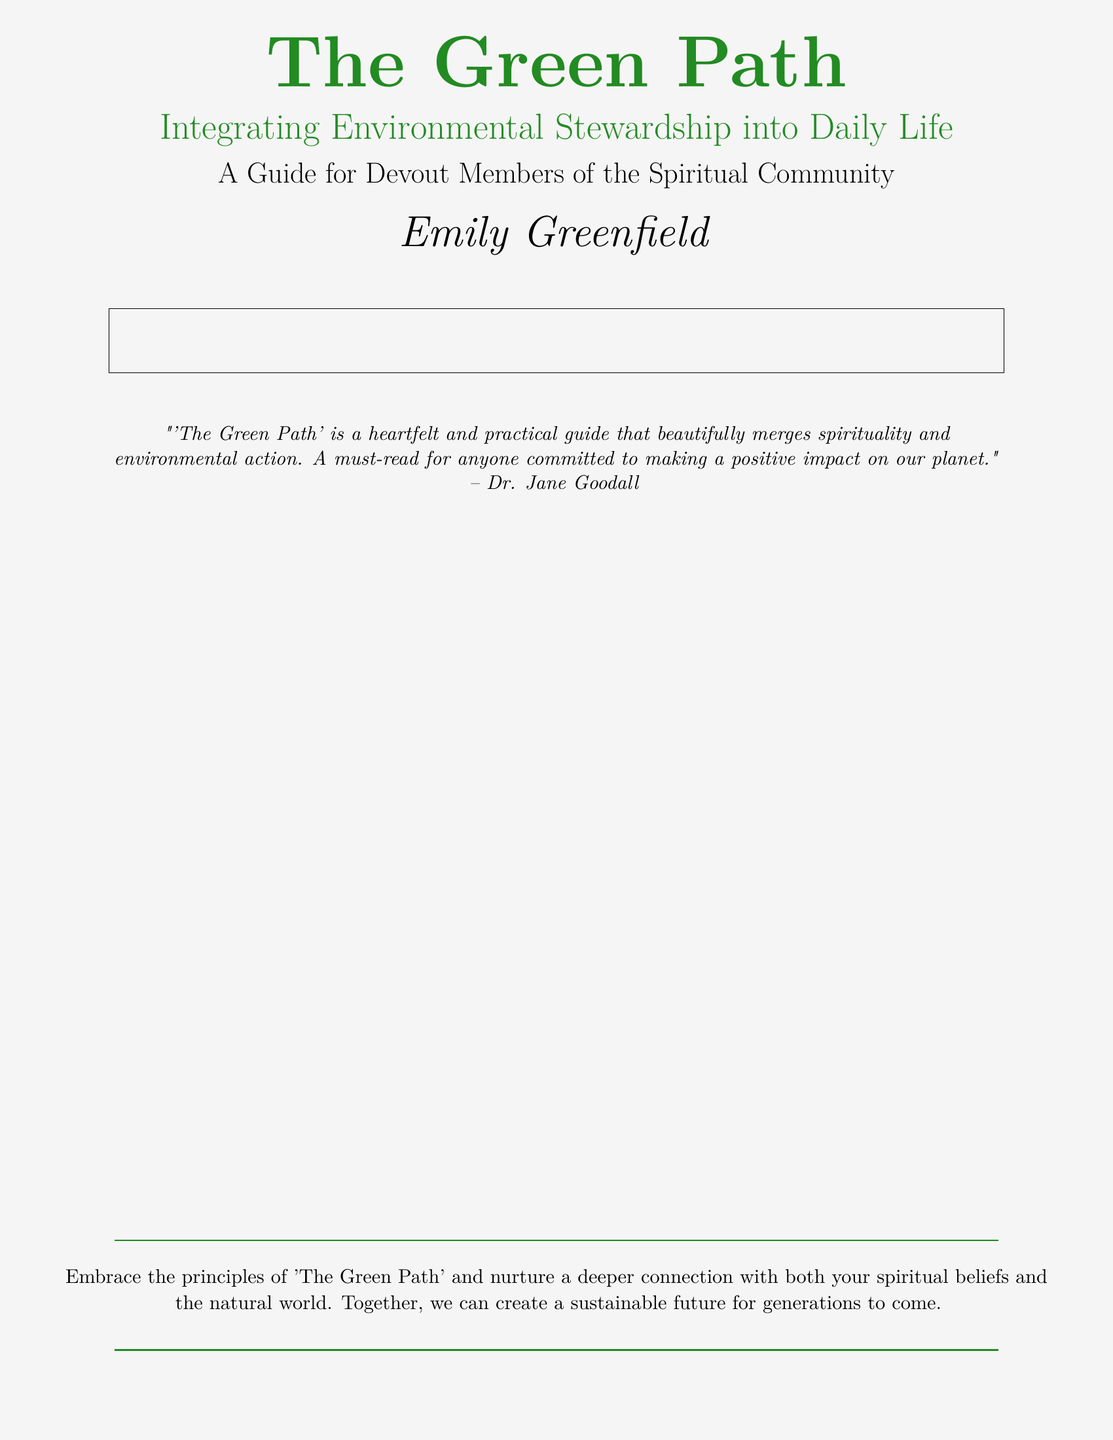what is the title of the book? The title of the book is prominently displayed at the top of the cover.
Answer: The Green Path who is the author of the book? The author's name is featured in a larger font near the bottom of the cover.
Answer: Emily Greenfield what is the subtitle of the book? The subtitle is located just below the title, providing additional context.
Answer: Integrating Environmental Stewardship into Daily Life which color is used for the title? The color of the title is indicated in the document's design specifications.
Answer: forestgreen what is one of the themes mentioned in the book? The themes are highlighted in the multicolumn section on the cover.
Answer: Community and Faith how does the book describe its purpose? The purpose is conveyed through a quote from a notable figure included on the cover.
Answer: to care for the Earth who is quoted on the cover? The quotation from a well-known environmentalist is cited on the cover.
Answer: Dr. Jane Goodall what type of guide is "The Green Path"? The guide's nature is specified in the subtitle of the book.
Answer: A guide for devout members of the spiritual community what does the book encourage readers to embrace? The conclusion of the document summarizes the book's encouragement to the readers.
Answer: the principles of 'The Green Path' 